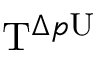Convert formula to latex. <formula><loc_0><loc_0><loc_500><loc_500>T ^ { \Delta p U }</formula> 